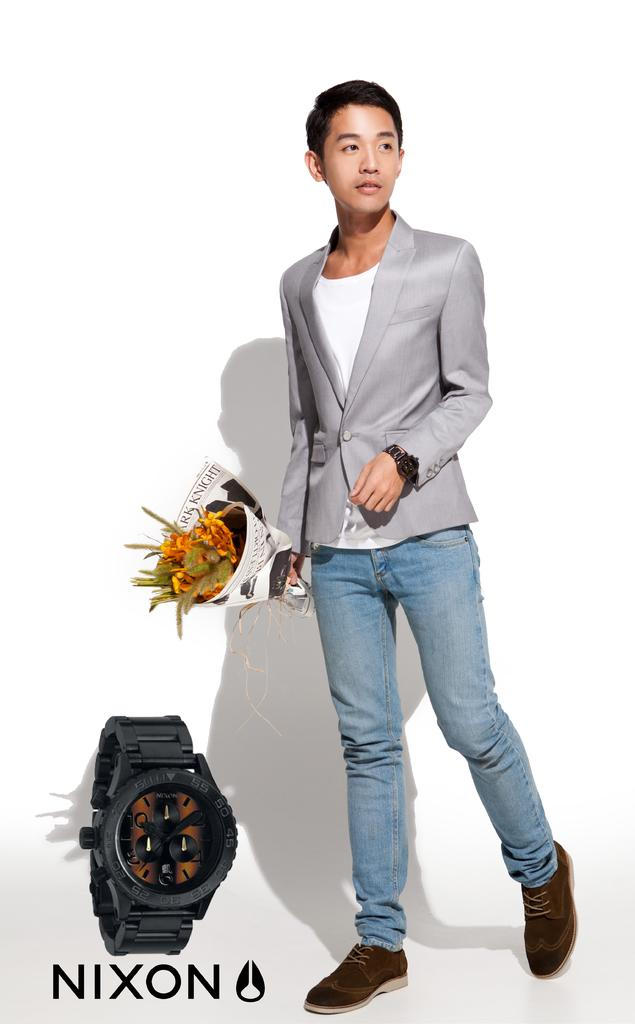<image>
Share a concise interpretation of the image provided. An advertisement for Nixon with a man holding a bouquet of flowers. 